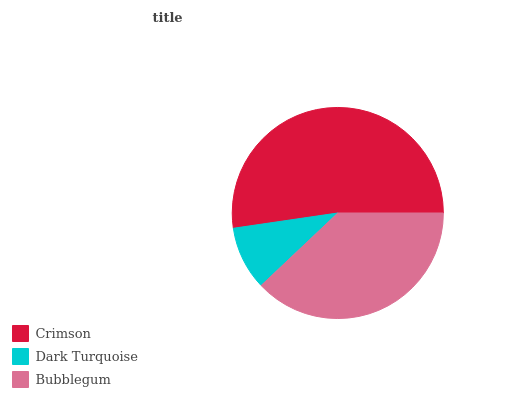Is Dark Turquoise the minimum?
Answer yes or no. Yes. Is Crimson the maximum?
Answer yes or no. Yes. Is Bubblegum the minimum?
Answer yes or no. No. Is Bubblegum the maximum?
Answer yes or no. No. Is Bubblegum greater than Dark Turquoise?
Answer yes or no. Yes. Is Dark Turquoise less than Bubblegum?
Answer yes or no. Yes. Is Dark Turquoise greater than Bubblegum?
Answer yes or no. No. Is Bubblegum less than Dark Turquoise?
Answer yes or no. No. Is Bubblegum the high median?
Answer yes or no. Yes. Is Bubblegum the low median?
Answer yes or no. Yes. Is Dark Turquoise the high median?
Answer yes or no. No. Is Crimson the low median?
Answer yes or no. No. 